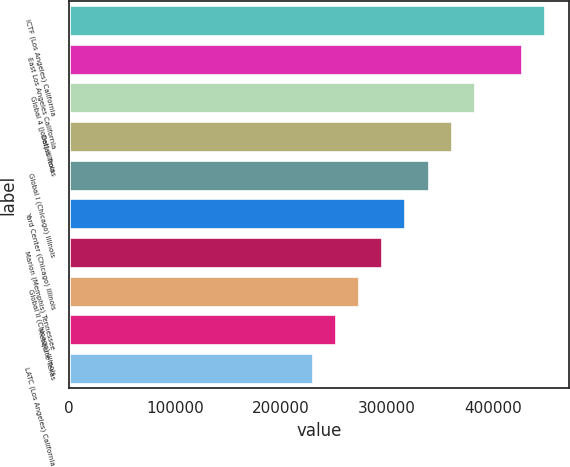Convert chart to OTSL. <chart><loc_0><loc_0><loc_500><loc_500><bar_chart><fcel>ICTF (Los Angeles) California<fcel>East Los Angeles California<fcel>Global 4 (Joliet) Illinois<fcel>Dallas Texas<fcel>Global I (Chicago) Illinois<fcel>Yard Center (Chicago) Illinois<fcel>Marion (Memphis) Tennessee<fcel>Global II (Chicago) Illinois<fcel>Mesquite Texas<fcel>LATC (Los Angeles) California<nl><fcel>448800<fcel>427000<fcel>382600<fcel>360800<fcel>339000<fcel>317200<fcel>295400<fcel>273600<fcel>251800<fcel>230000<nl></chart> 